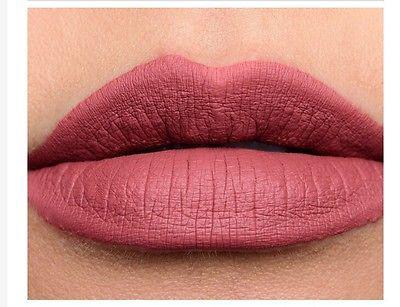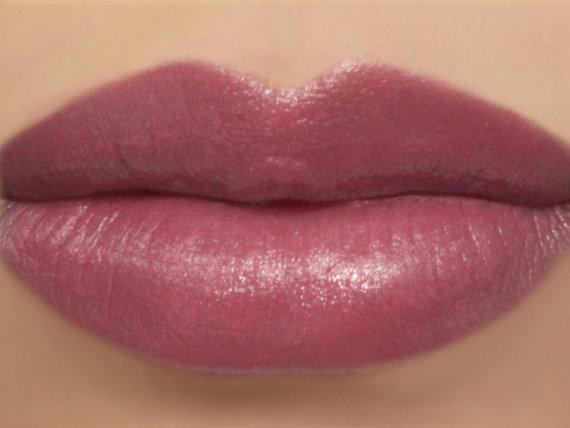The first image is the image on the left, the second image is the image on the right. Examine the images to the left and right. Is the description "A lipstick swatch is shown on a person's lip in both images." accurate? Answer yes or no. Yes. The first image is the image on the left, the second image is the image on the right. Examine the images to the left and right. Is the description "The right image contains human lips with lipstick on them." accurate? Answer yes or no. Yes. 